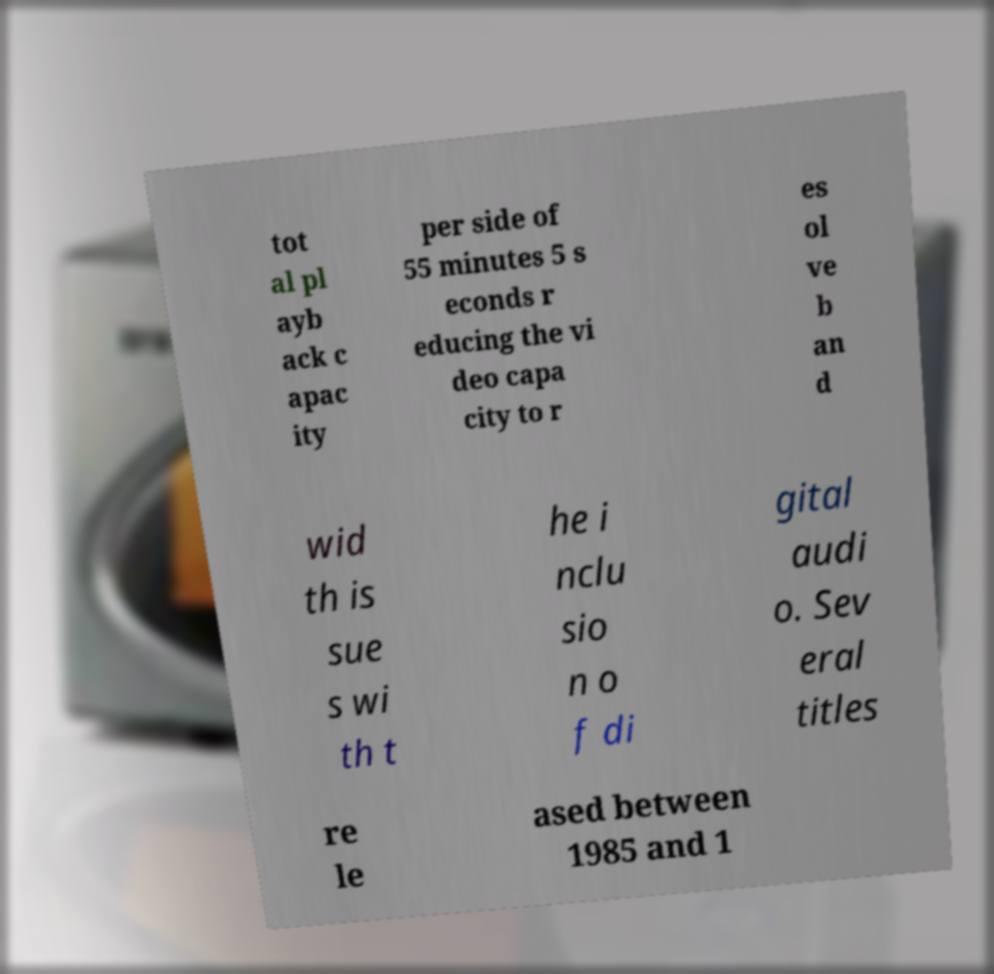What messages or text are displayed in this image? I need them in a readable, typed format. tot al pl ayb ack c apac ity per side of 55 minutes 5 s econds r educing the vi deo capa city to r es ol ve b an d wid th is sue s wi th t he i nclu sio n o f di gital audi o. Sev eral titles re le ased between 1985 and 1 